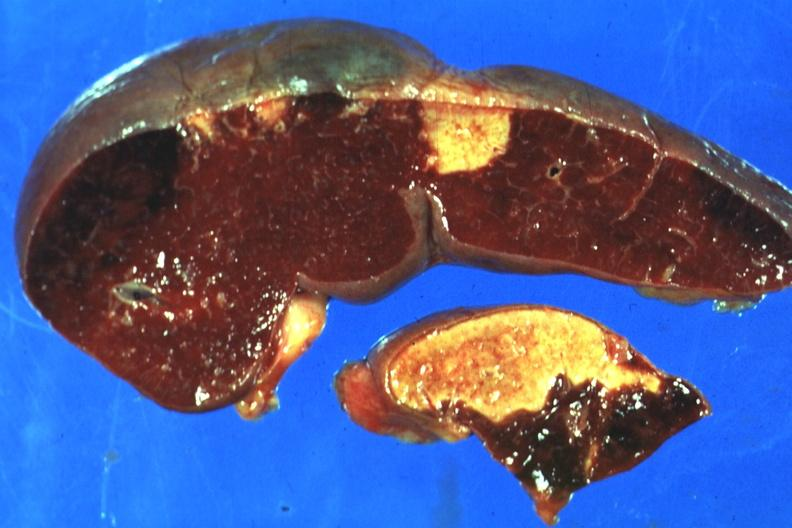what does this image show?
Answer the question using a single word or phrase. Excellent side with four infarcts shown which are several days of age from nonbacterial endocarditis 